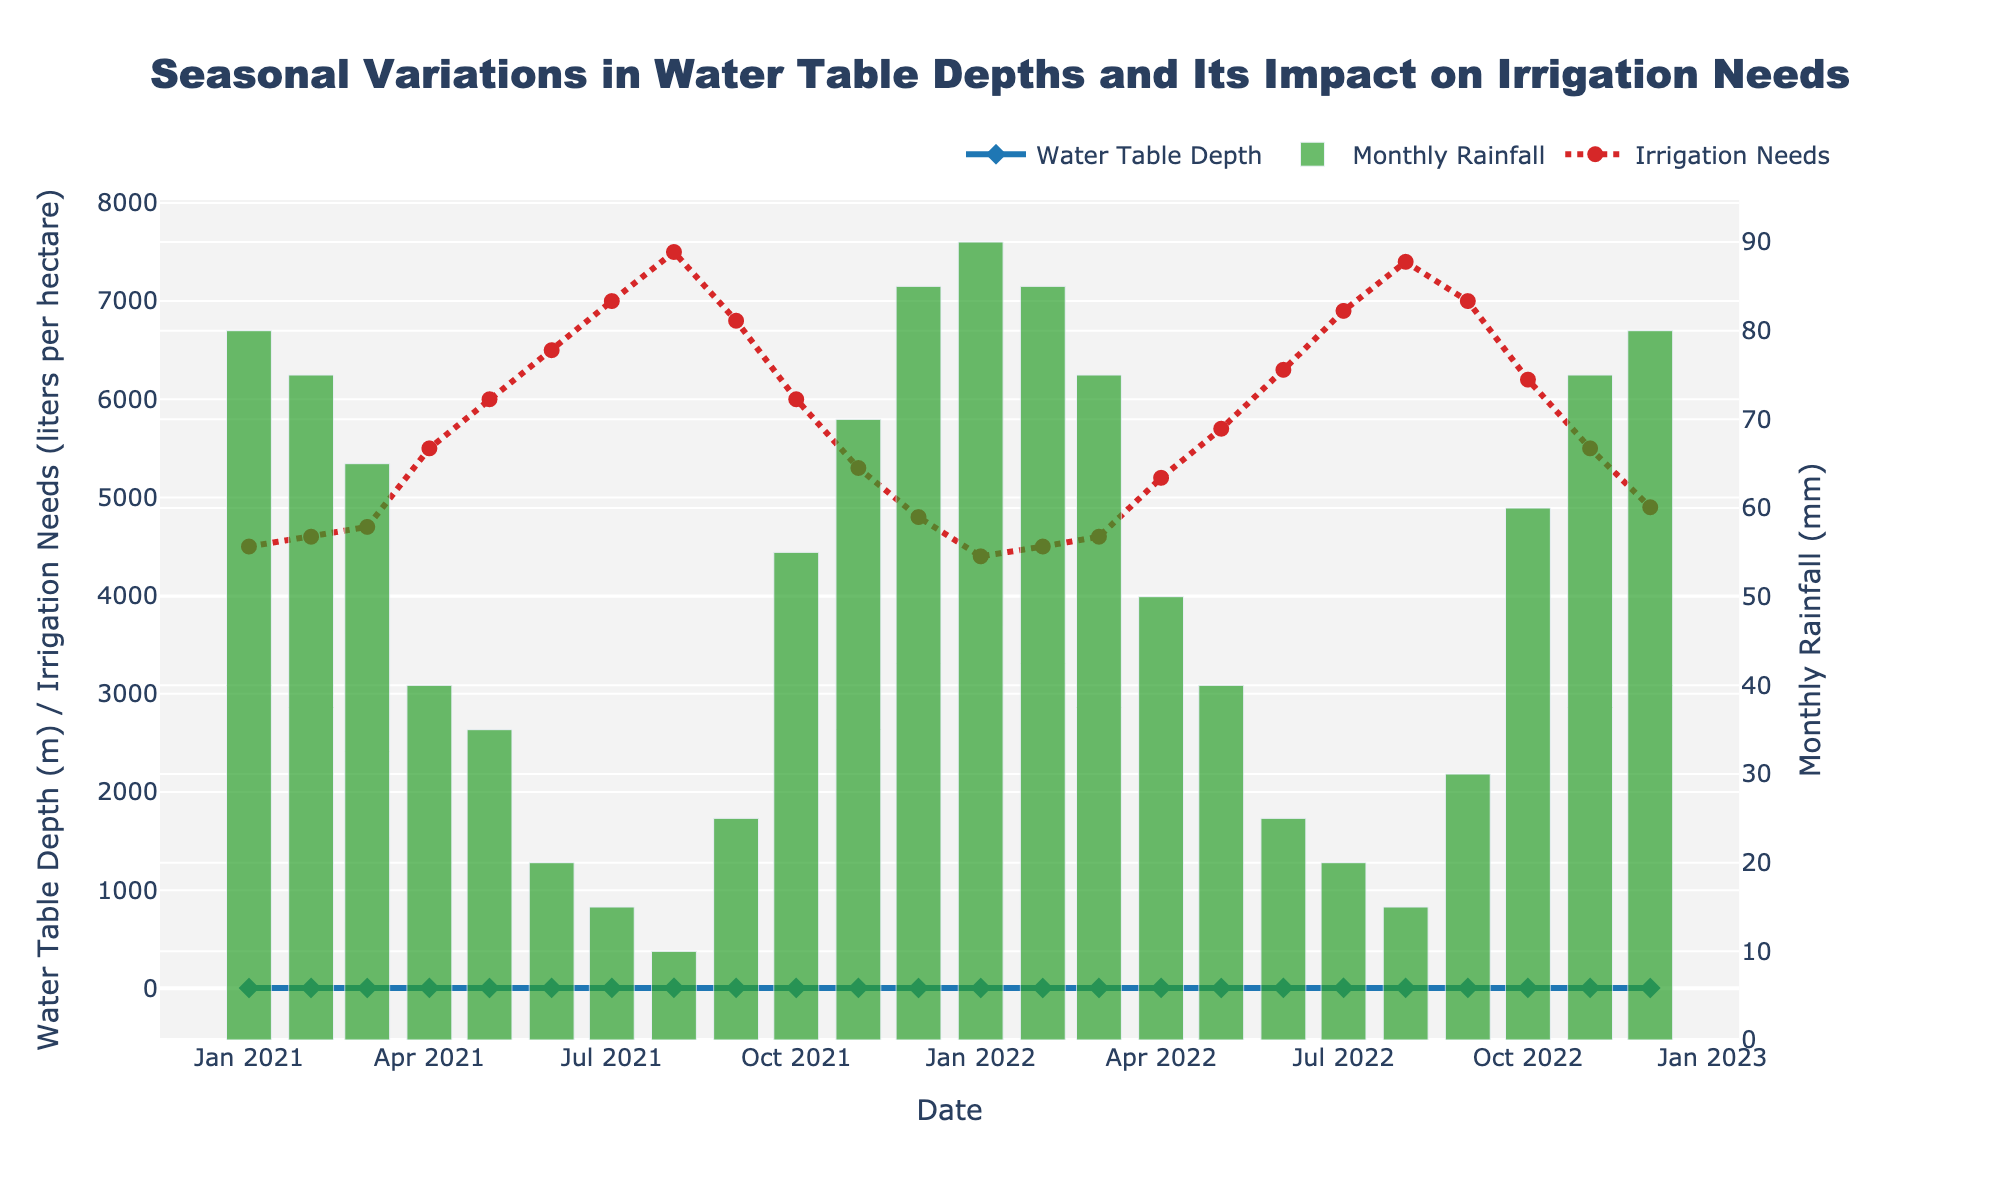What is the title of the figure? The title of the figure is located at the top center of the plot. It generally provides a brief description of the data visualized in the figure.
Answer: Seasonal Variations in Water Table Depths and Its Impact on Irrigation Needs Which line represents the Water Table Depth? The Water Table Depth is represented by the blue line with diamond-shaped markers according to the figure legend.
Answer: Blue line with diamond markers When is the monthly rainfall the highest, and what is its value? To find the highest monthly rainfall, check the height of the green bars. The tallest bar occurs in January 2022, and its value can be read on the secondary y-axis for Monthly Rainfall.
Answer: January 2022, 90 mm How has the Water Table Depth changed from January 2021 to January 2022? Identify the Water Table Depth data points for January 2021 and January 2022, and calculate the difference. For January 2021, the depth is 3.5 meters, and for January 2022, it is 3.6 meters which shows a slight increase.
Answer: Increased by 0.1 meters During which month and year did the irrigation needs peak, and what was the irrigation requirement then? Look at the red dashed line and identify the peak point. This occurs in August 2021, and the value, as indicated on the primary y-axis, is 7500 liters per hectare.
Answer: August 2021, 7500 liters per hectare What is the general trend of 'Water Table Depth' and 'Monthly Rainfall' from January to August each year? First, observe the blue line for Water Table Depths from January to August. Note the increasing trend. Then check the green bars for Monthly Rainfall over the same period; it shows a decreasing trend. This pattern repeats for both years.
Answer: Water Table Depth increases, Monthly Rainfall decreases What is the difference in irrigation needs between June 2021 and June 2022? Find the irrigation need values for June 2021 and June 2022 on the red line. In June 2021, it was 6500 liters per hectare, and in June 2022, it was 6300 liters per hectare. The difference is 6500 - 6300 = 200 liters per hectare.
Answer: 200 liters per hectare How does Water Table Depth correlate with Irrigation Needs throughout the two years? Observe the overall trends of the blue line (Water Table Depth) and red dotted line (Irrigation Needs). When the Water Table Depth increases, irrigation needs tend to increase as well, indicating a positive correlation.
Answer: Positive correlation In which month and year does the Water Table Depth reach its lowest value, and what is that value? Identify the lowest point on the blue line for Water Table Depth. The lowest value occurs in August 2022 and is 5.1 meters.
Answer: August 2022, 5.1 meters How do the irrigation needs in October 2021 compare with October 2022? Locate the irrigation needs data points in October 2021 and October 2022 on the red line. In October 2021, the value is 6000 liters per hectare, and in October 2022, it is 6200 liters per hectare, showing an increase.
Answer: October 2022 is higher by 200 liters per hectare 